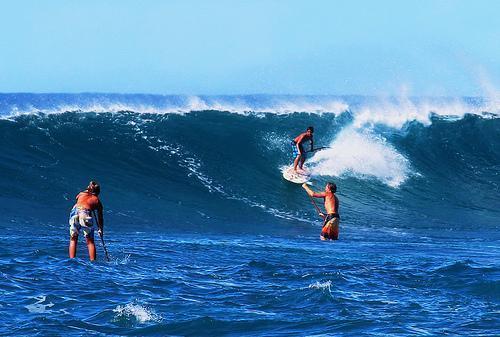How many surfers are in the ocean?
Give a very brief answer. 3. 